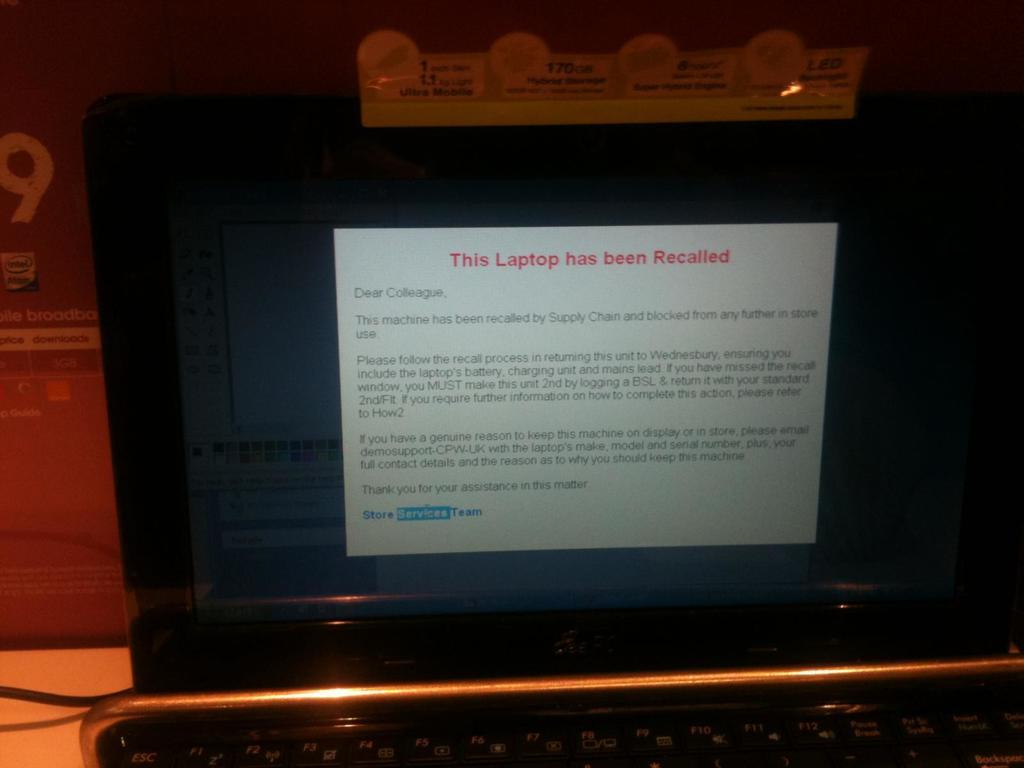<image>
Offer a succinct explanation of the picture presented. A black laptop with the word This Laptop Has Been Recalled on the screen 